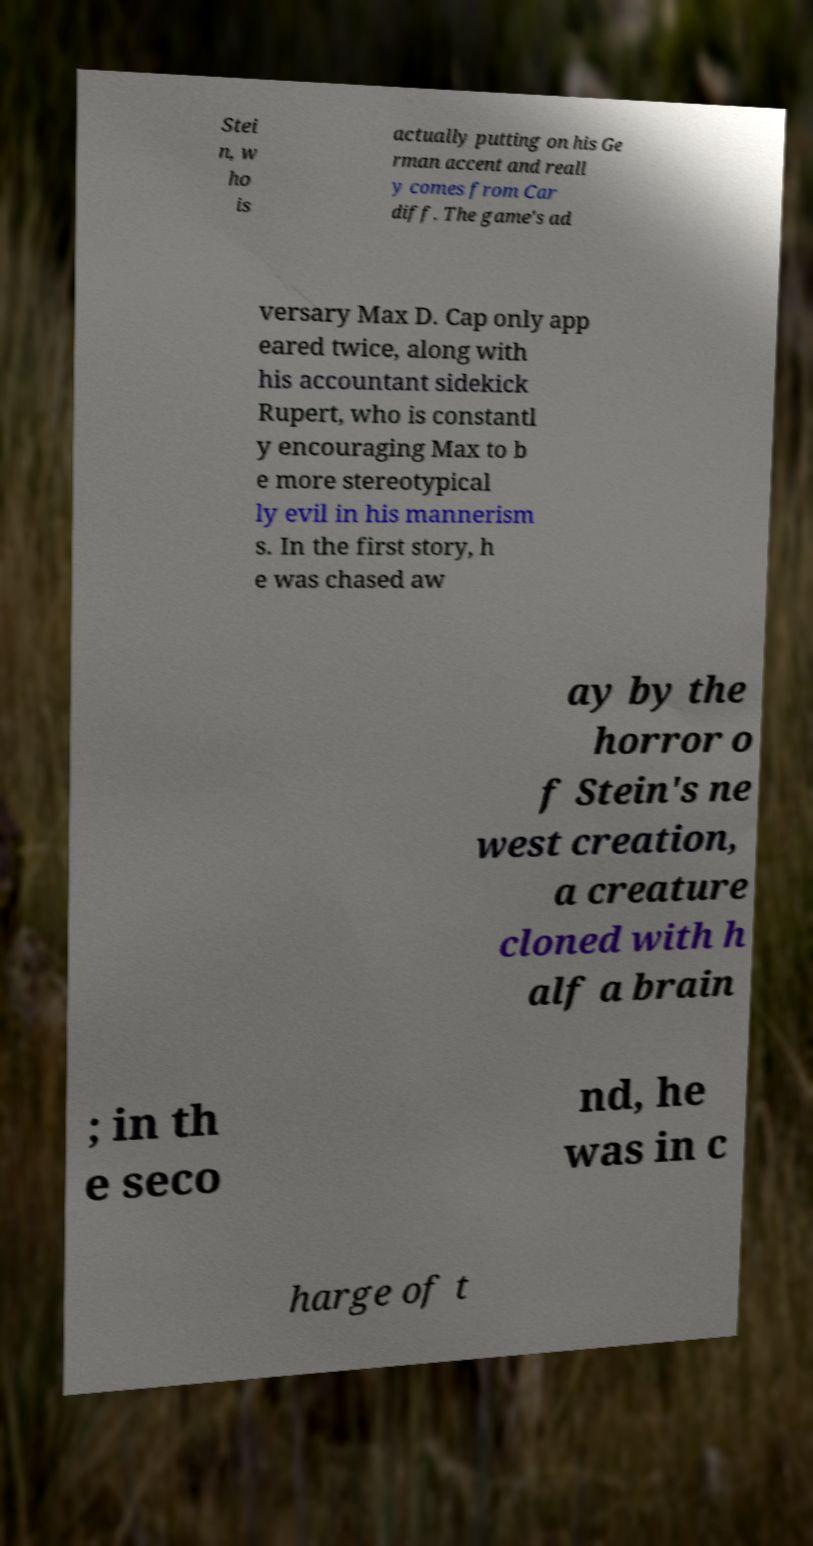For documentation purposes, I need the text within this image transcribed. Could you provide that? Stei n, w ho is actually putting on his Ge rman accent and reall y comes from Car diff. The game's ad versary Max D. Cap only app eared twice, along with his accountant sidekick Rupert, who is constantl y encouraging Max to b e more stereotypical ly evil in his mannerism s. In the first story, h e was chased aw ay by the horror o f Stein's ne west creation, a creature cloned with h alf a brain ; in th e seco nd, he was in c harge of t 